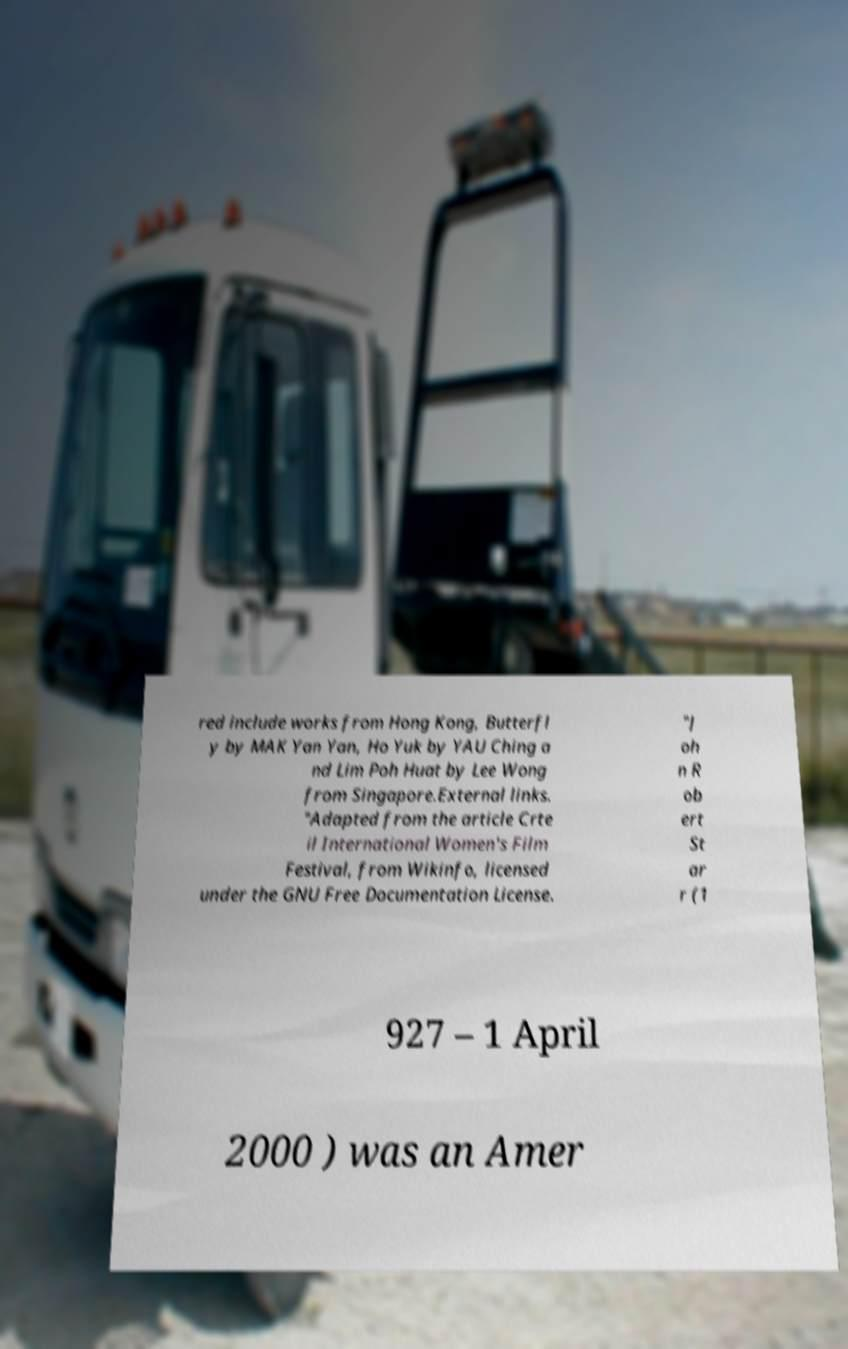Please identify and transcribe the text found in this image. red include works from Hong Kong, Butterfl y by MAK Yan Yan, Ho Yuk by YAU Ching a nd Lim Poh Huat by Lee Wong from Singapore.External links. "Adapted from the article Crte il International Women's Film Festival, from Wikinfo, licensed under the GNU Free Documentation License. "J oh n R ob ert St ar r (1 927 – 1 April 2000 ) was an Amer 